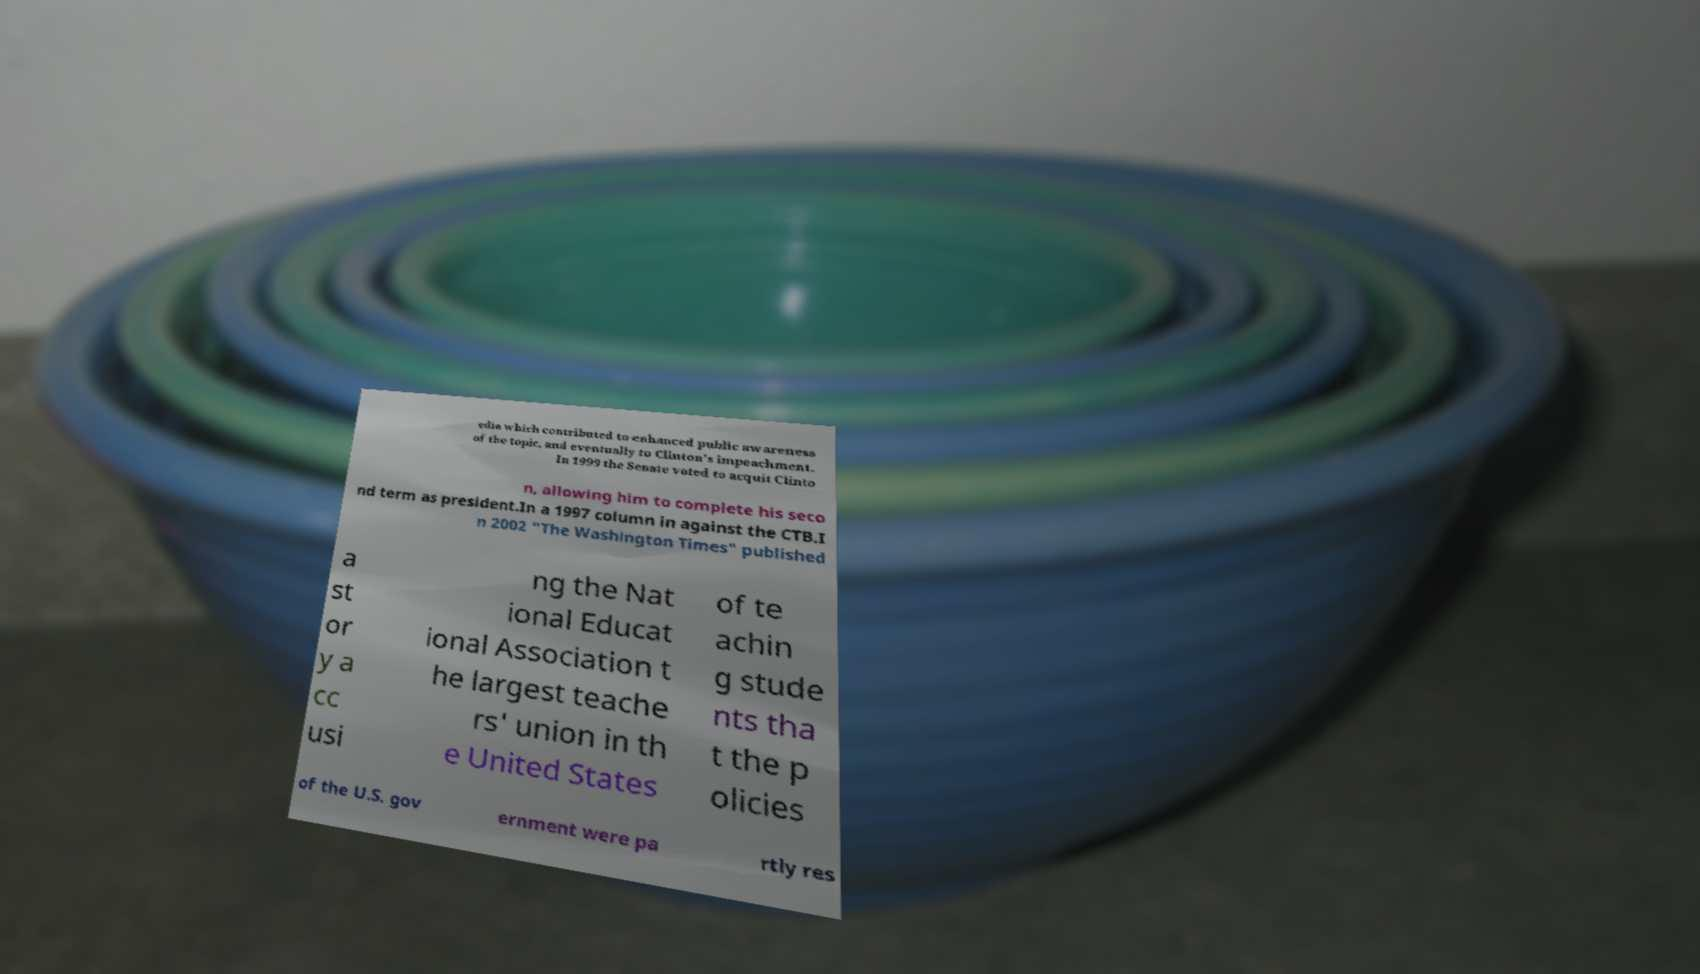For documentation purposes, I need the text within this image transcribed. Could you provide that? edia which contributed to enhanced public awareness of the topic, and eventually to Clinton's impeachment. In 1999 the Senate voted to acquit Clinto n, allowing him to complete his seco nd term as president.In a 1997 column in against the CTB.I n 2002 "The Washington Times" published a st or y a cc usi ng the Nat ional Educat ional Association t he largest teache rs' union in th e United States of te achin g stude nts tha t the p olicies of the U.S. gov ernment were pa rtly res 